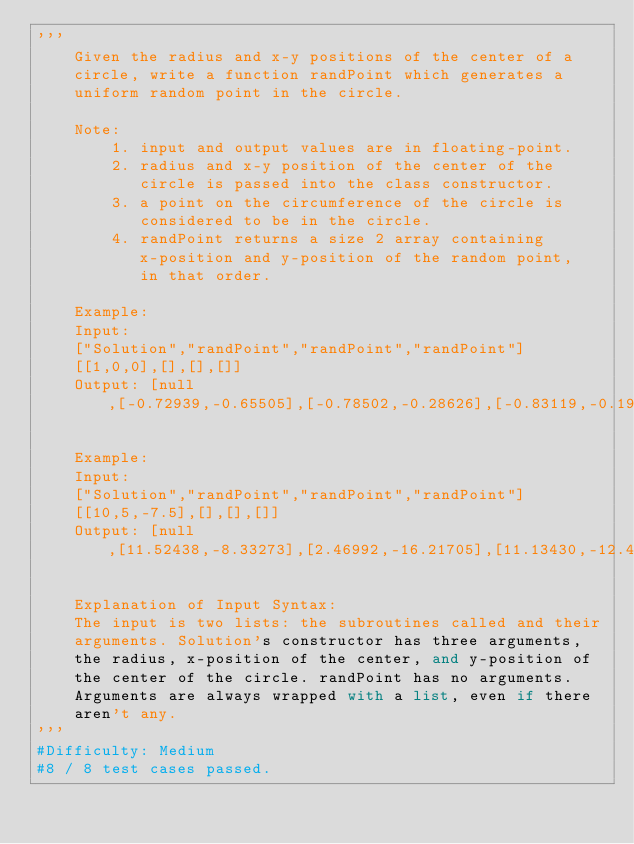Convert code to text. <code><loc_0><loc_0><loc_500><loc_500><_Python_>'''
    Given the radius and x-y positions of the center of a 
    circle, write a function randPoint which generates a 
    uniform random point in the circle.

    Note:
        1. input and output values are in floating-point.
        2. radius and x-y position of the center of the 
           circle is passed into the class constructor.
        3. a point on the circumference of the circle is 
           considered to be in the circle.
        4. randPoint returns a size 2 array containing 
           x-position and y-position of the random point, 
           in that order.

    Example:
    Input: 
    ["Solution","randPoint","randPoint","randPoint"]
    [[1,0,0],[],[],[]]
    Output: [null,[-0.72939,-0.65505],[-0.78502,-0.28626],[-0.83119,-0.19803]]

    Example:
    Input: 
    ["Solution","randPoint","randPoint","randPoint"]
    [[10,5,-7.5],[],[],[]]
    Output: [null,[11.52438,-8.33273],[2.46992,-16.21705],[11.13430,-12.42337]]

    Explanation of Input Syntax:
    The input is two lists: the subroutines called and their 
    arguments. Solution's constructor has three arguments, 
    the radius, x-position of the center, and y-position of 
    the center of the circle. randPoint has no arguments. 
    Arguments are always wrapped with a list, even if there 
    aren't any.
'''
#Difficulty: Medium
#8 / 8 test cases passed.</code> 